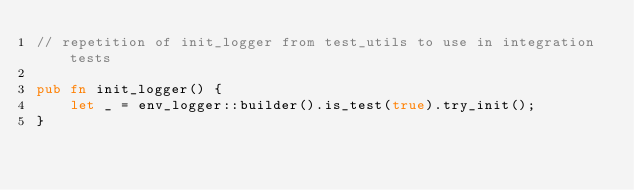<code> <loc_0><loc_0><loc_500><loc_500><_Rust_>// repetition of init_logger from test_utils to use in integration tests

pub fn init_logger() {
    let _ = env_logger::builder().is_test(true).try_init();
}
</code> 